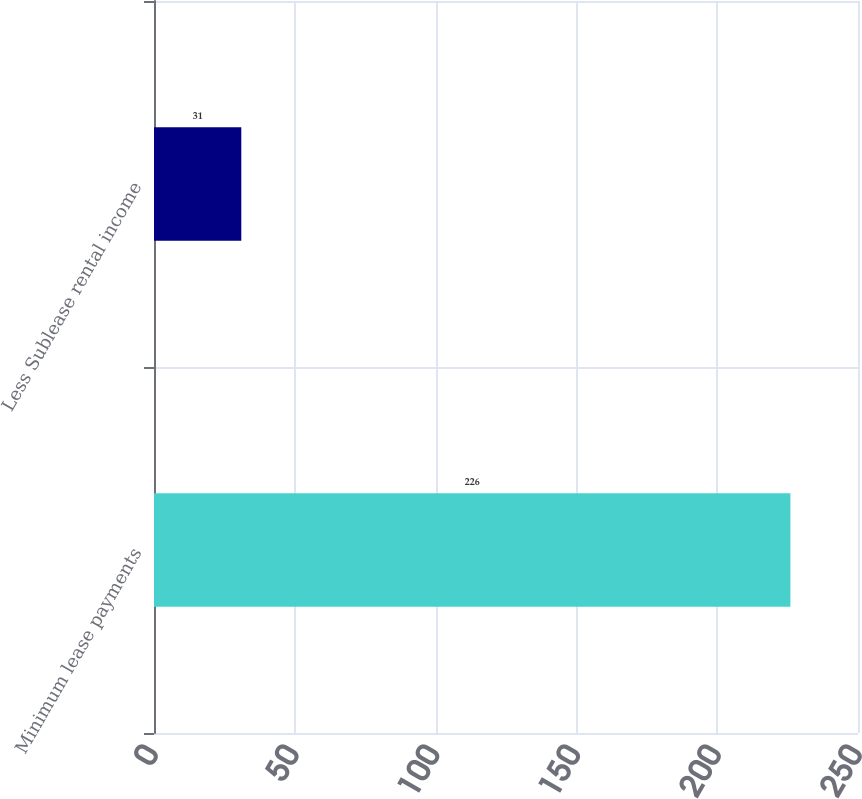Convert chart. <chart><loc_0><loc_0><loc_500><loc_500><bar_chart><fcel>Minimum lease payments<fcel>Less Sublease rental income<nl><fcel>226<fcel>31<nl></chart> 